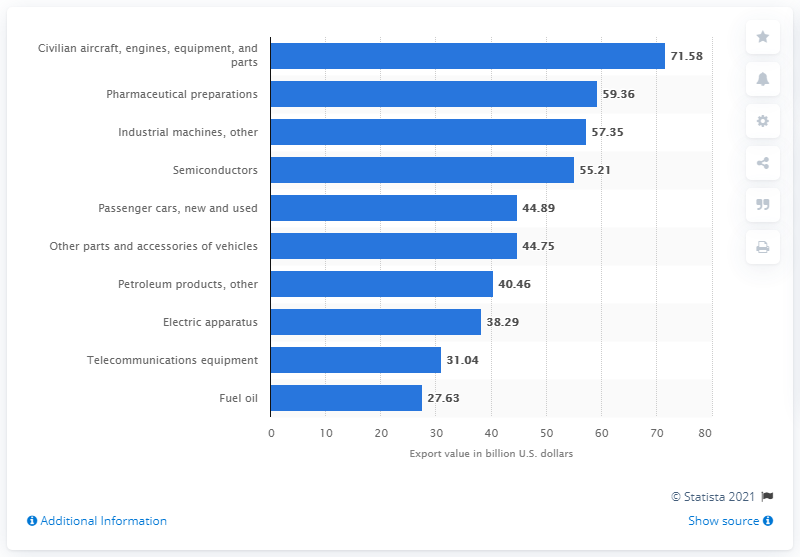List a handful of essential elements in this visual. In 2020, the value of new and used passenger vehicles exported to the United States was $44.89 billion. 